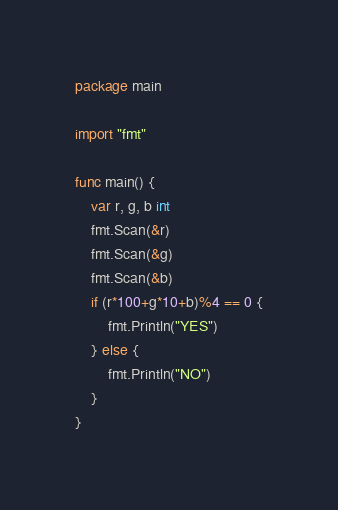<code> <loc_0><loc_0><loc_500><loc_500><_Go_>package main

import "fmt"

func main() {
	var r, g, b int
	fmt.Scan(&r)
	fmt.Scan(&g)
	fmt.Scan(&b)
	if (r*100+g*10+b)%4 == 0 {
		fmt.Println("YES")
	} else {
		fmt.Println("NO")
	}
}
</code> 